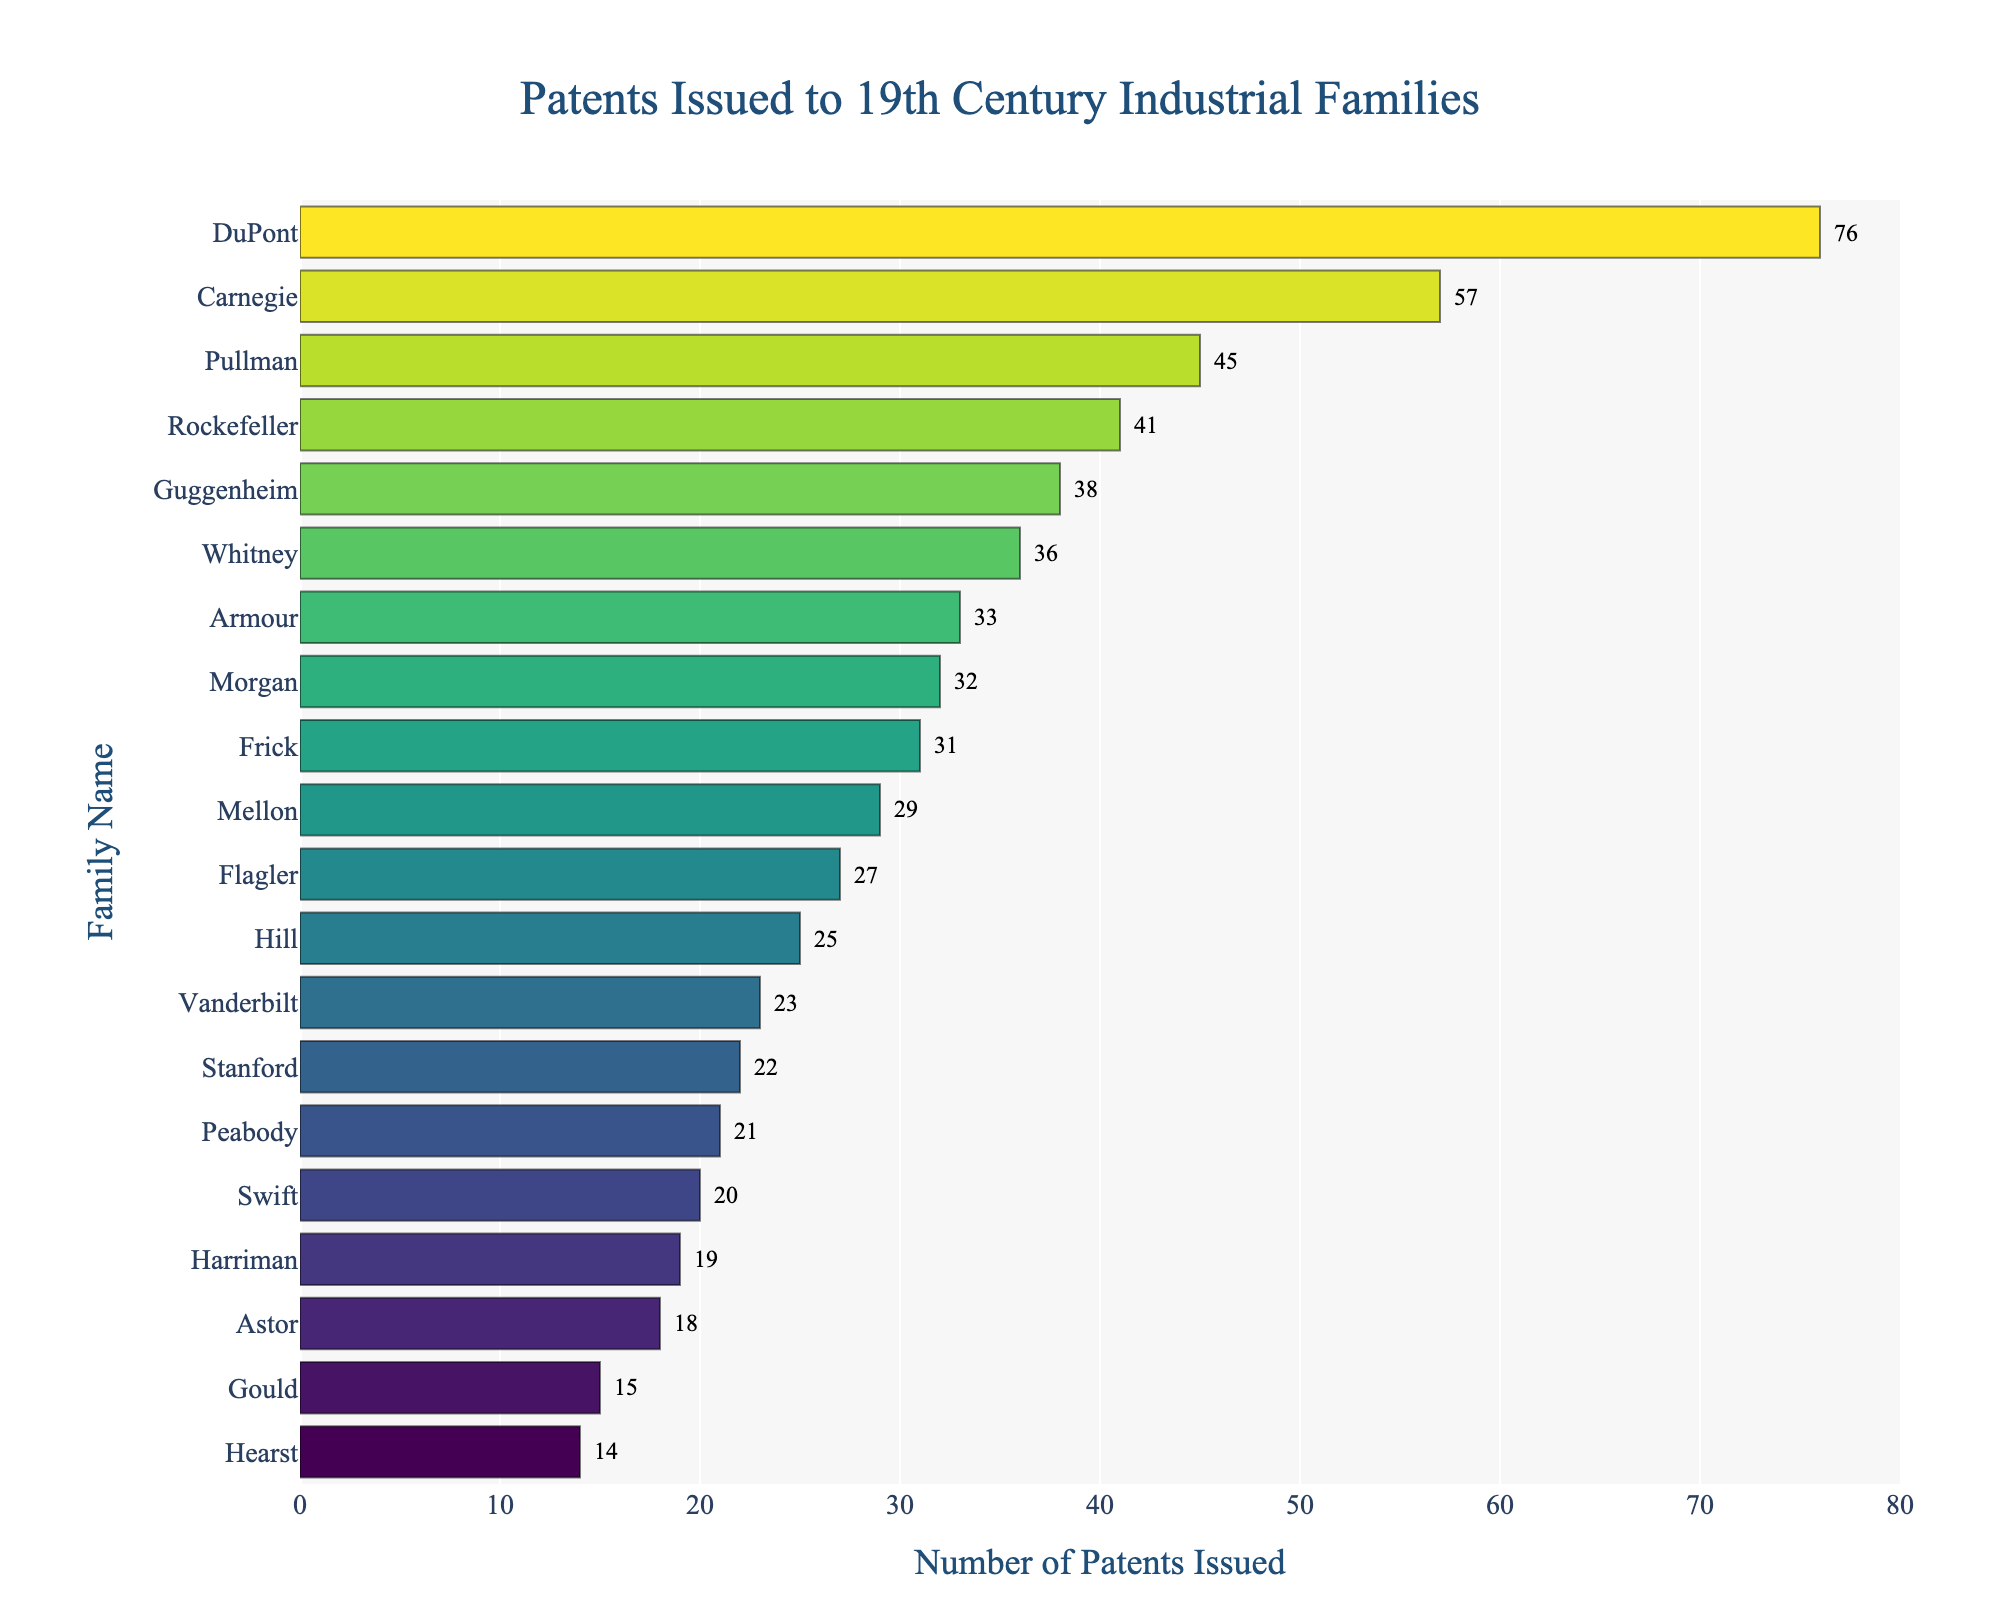Which family has the most patents issued? The chart shows the number of patents issued for each family. The family with the most patents is at the top of the chart.
Answer: DuPont Which family has the fewest patents issued? The chart shows the number of patents issued for each family. The family with the fewest patents is at the bottom of the chart.
Answer: Hearst How many more patents does the Carnegie family have compared to the Mellon family? From the chart, Carnegie has 57 patents and Mellon has 29 patents. The difference is 57 - 29.
Answer: 28 What is the total number of patents issued to the Vanderbilt, Rockefeller, and Carnegie families combined? From the chart, Vanderbilt has 23 patents, Rockefeller has 41, and Carnegie has 57. Adding them together, 23 + 41 + 57.
Answer: 121 Which family has exactly 45 patents issued? By looking at the labels on the chart next to the bars, we can see that the Pullman family has exactly 45 patents.
Answer: Pullman How does the number of patents issued to the Morgan family compare to the Guggenheim family? Morgan has 32 patents, while Guggenheim has 38 patents. Comparing these two values.
Answer: Morgan has 6 fewer Which family is positioned directly above the Gould family? Observing the chart, the family directly above the Gould family, which has 15 patents, is the Hearst family with 14 patents.
Answer: Hearst What's the average number of patents issued to the Astor and Stanford families? From the chart, Astor has 18 patents and Stanford has 22 patents. (18 + 22) / 2.
Answer: 20 By how many patents does the Armour family exceed the Hill family? Armour has 33 patents, and Hill has 25 patents. The difference is 33 - 25.
Answer: 8 Which family has a patent count closest to the median number of patents across all families? Sorting the families by the number of patents, we find the median value around the middle. With 20 families, the median value position is between the 10th and 11th ranked families. From the data, Flagler has 27 patents and Armour has 33 patents, so Flagler's number is closer to the mid-point.
Answer: Flagler 